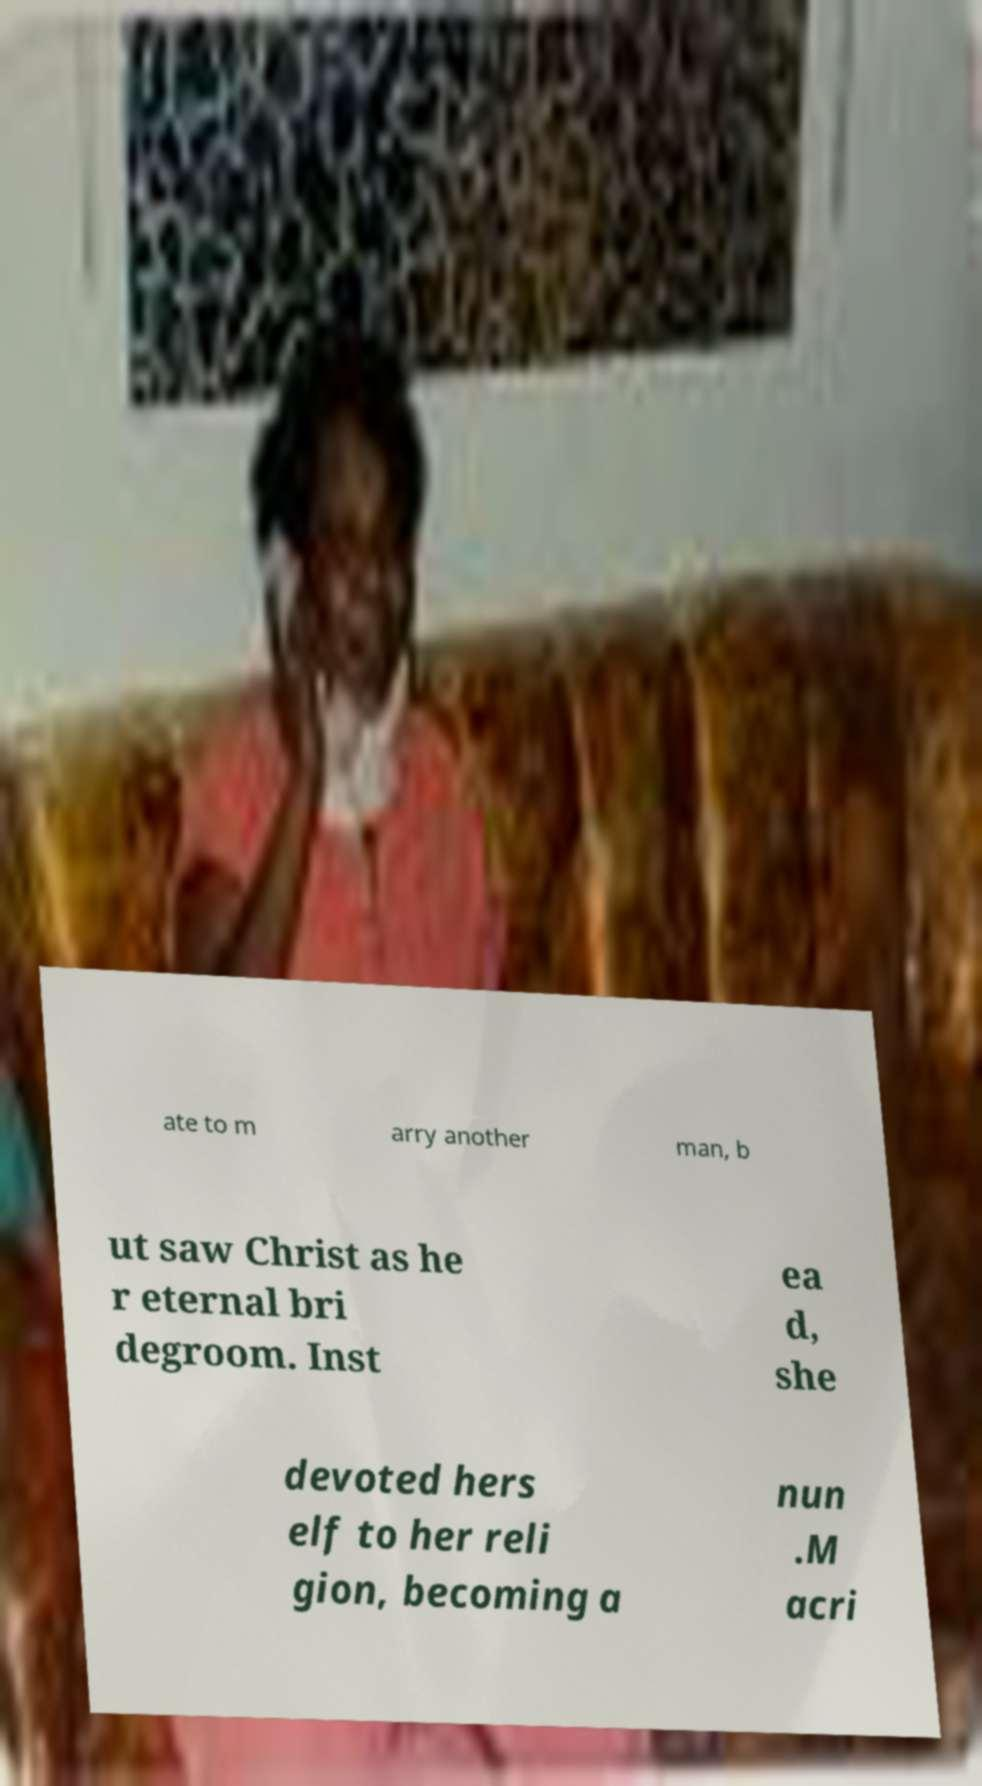For documentation purposes, I need the text within this image transcribed. Could you provide that? ate to m arry another man, b ut saw Christ as he r eternal bri degroom. Inst ea d, she devoted hers elf to her reli gion, becoming a nun .M acri 